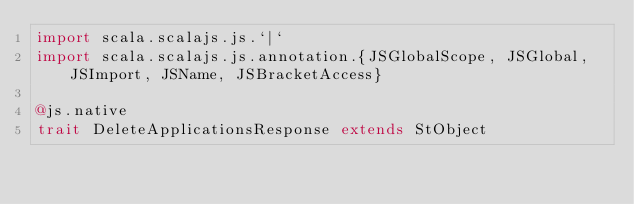<code> <loc_0><loc_0><loc_500><loc_500><_Scala_>import scala.scalajs.js.`|`
import scala.scalajs.js.annotation.{JSGlobalScope, JSGlobal, JSImport, JSName, JSBracketAccess}

@js.native
trait DeleteApplicationsResponse extends StObject
</code> 